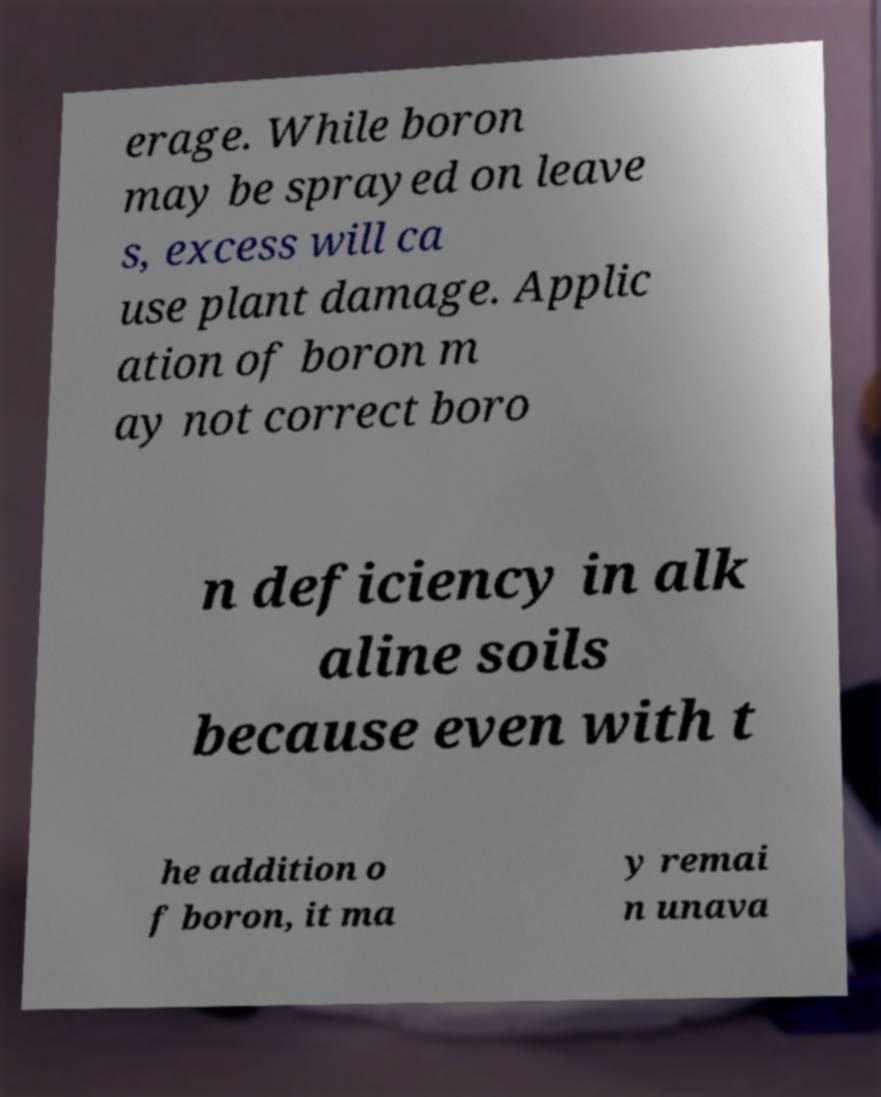Can you accurately transcribe the text from the provided image for me? erage. While boron may be sprayed on leave s, excess will ca use plant damage. Applic ation of boron m ay not correct boro n deficiency in alk aline soils because even with t he addition o f boron, it ma y remai n unava 